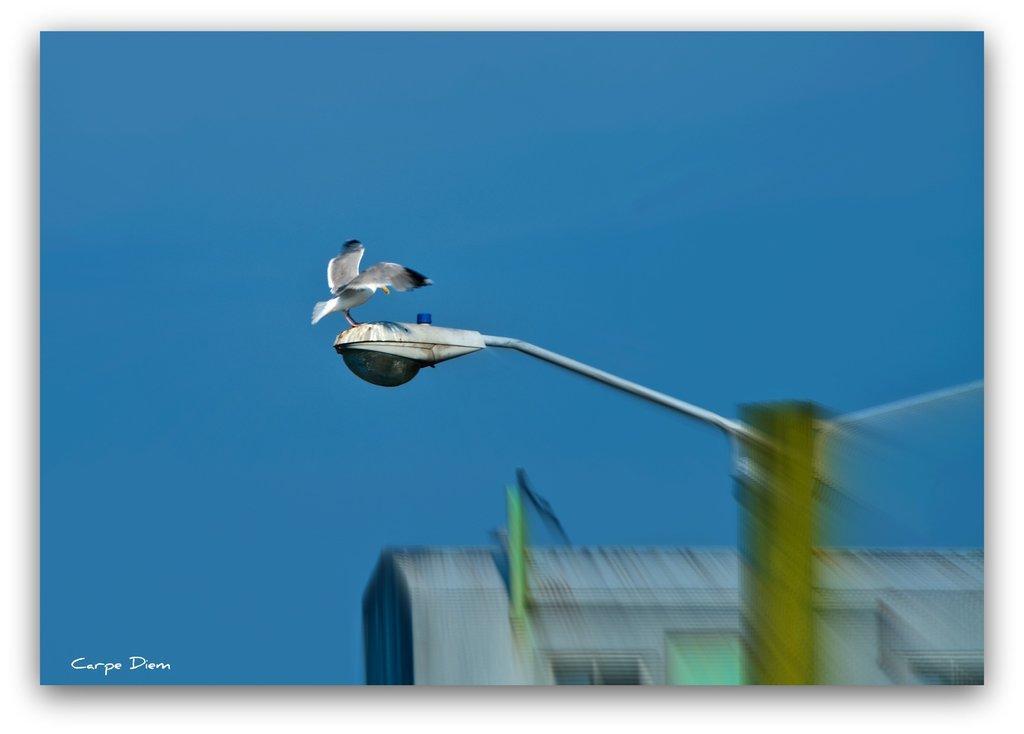Could you give a brief overview of what you see in this image? In this image we can see a bird standing on the street light. In the background we can see building and sky. 